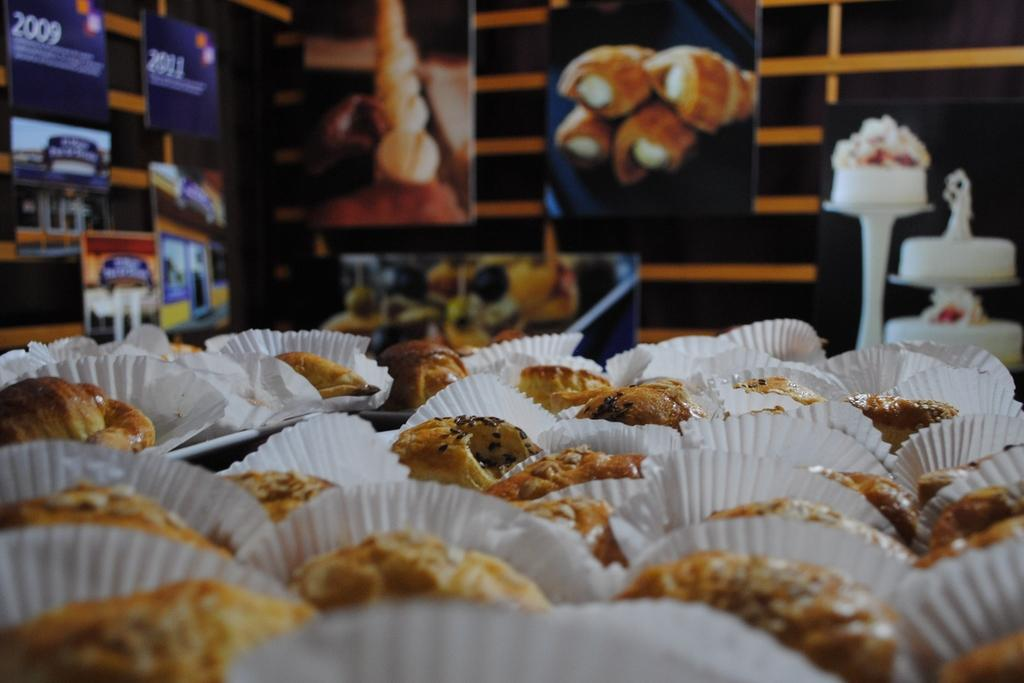What type of food items can be seen in the image? There are cupcakes in the image. Where are the cupcakes located in the image? The cupcakes are at the bottom of the image. What other food-related items can be seen in the image? There are photo frames of food items in the image. What can be seen on the wall in the image? There are posters on the wall in the image. Can you tell me how many pigs are visible on the roof in the image? There are no pigs visible on the roof in the image, as the image does not depict a roof or any pigs. 